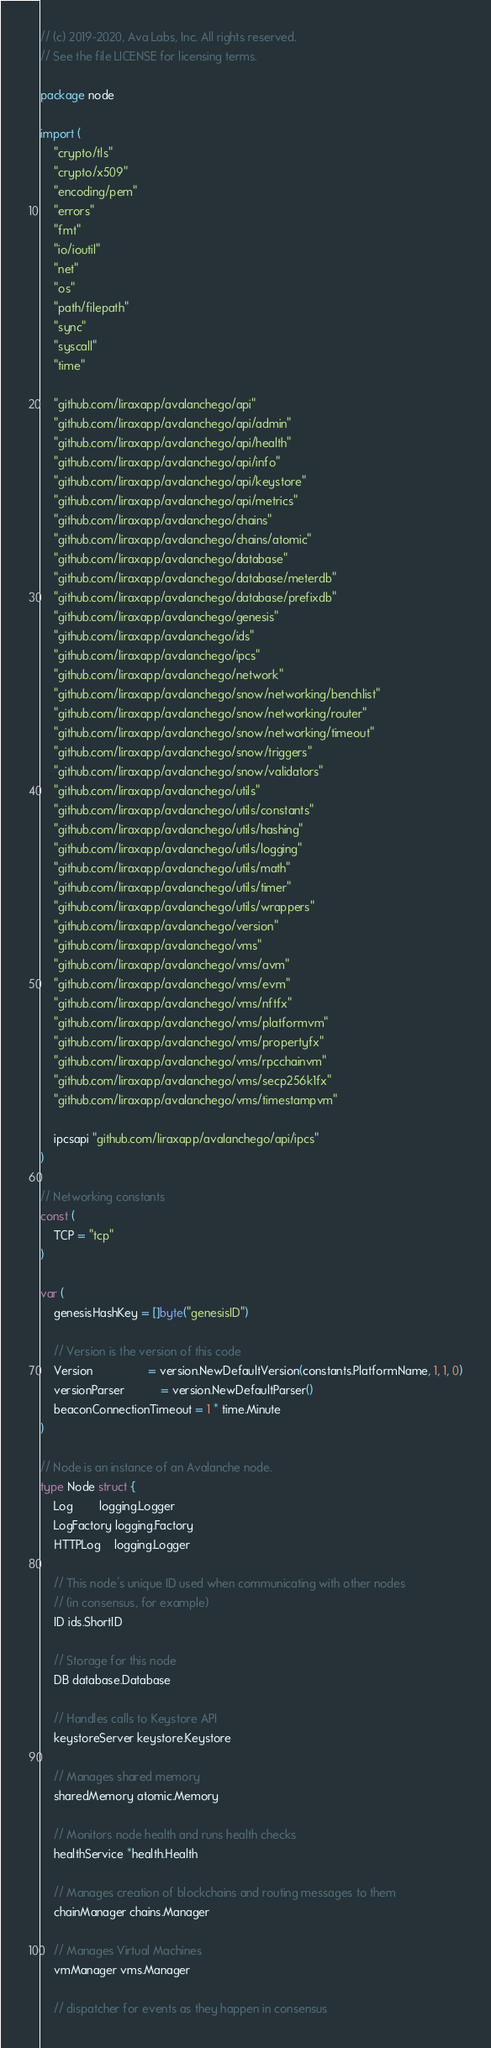Convert code to text. <code><loc_0><loc_0><loc_500><loc_500><_Go_>// (c) 2019-2020, Ava Labs, Inc. All rights reserved.
// See the file LICENSE for licensing terms.

package node

import (
	"crypto/tls"
	"crypto/x509"
	"encoding/pem"
	"errors"
	"fmt"
	"io/ioutil"
	"net"
	"os"
	"path/filepath"
	"sync"
	"syscall"
	"time"

	"github.com/liraxapp/avalanchego/api"
	"github.com/liraxapp/avalanchego/api/admin"
	"github.com/liraxapp/avalanchego/api/health"
	"github.com/liraxapp/avalanchego/api/info"
	"github.com/liraxapp/avalanchego/api/keystore"
	"github.com/liraxapp/avalanchego/api/metrics"
	"github.com/liraxapp/avalanchego/chains"
	"github.com/liraxapp/avalanchego/chains/atomic"
	"github.com/liraxapp/avalanchego/database"
	"github.com/liraxapp/avalanchego/database/meterdb"
	"github.com/liraxapp/avalanchego/database/prefixdb"
	"github.com/liraxapp/avalanchego/genesis"
	"github.com/liraxapp/avalanchego/ids"
	"github.com/liraxapp/avalanchego/ipcs"
	"github.com/liraxapp/avalanchego/network"
	"github.com/liraxapp/avalanchego/snow/networking/benchlist"
	"github.com/liraxapp/avalanchego/snow/networking/router"
	"github.com/liraxapp/avalanchego/snow/networking/timeout"
	"github.com/liraxapp/avalanchego/snow/triggers"
	"github.com/liraxapp/avalanchego/snow/validators"
	"github.com/liraxapp/avalanchego/utils"
	"github.com/liraxapp/avalanchego/utils/constants"
	"github.com/liraxapp/avalanchego/utils/hashing"
	"github.com/liraxapp/avalanchego/utils/logging"
	"github.com/liraxapp/avalanchego/utils/math"
	"github.com/liraxapp/avalanchego/utils/timer"
	"github.com/liraxapp/avalanchego/utils/wrappers"
	"github.com/liraxapp/avalanchego/version"
	"github.com/liraxapp/avalanchego/vms"
	"github.com/liraxapp/avalanchego/vms/avm"
	"github.com/liraxapp/avalanchego/vms/evm"
	"github.com/liraxapp/avalanchego/vms/nftfx"
	"github.com/liraxapp/avalanchego/vms/platformvm"
	"github.com/liraxapp/avalanchego/vms/propertyfx"
	"github.com/liraxapp/avalanchego/vms/rpcchainvm"
	"github.com/liraxapp/avalanchego/vms/secp256k1fx"
	"github.com/liraxapp/avalanchego/vms/timestampvm"

	ipcsapi "github.com/liraxapp/avalanchego/api/ipcs"
)

// Networking constants
const (
	TCP = "tcp"
)

var (
	genesisHashKey = []byte("genesisID")

	// Version is the version of this code
	Version                 = version.NewDefaultVersion(constants.PlatformName, 1, 1, 0)
	versionParser           = version.NewDefaultParser()
	beaconConnectionTimeout = 1 * time.Minute
)

// Node is an instance of an Avalanche node.
type Node struct {
	Log        logging.Logger
	LogFactory logging.Factory
	HTTPLog    logging.Logger

	// This node's unique ID used when communicating with other nodes
	// (in consensus, for example)
	ID ids.ShortID

	// Storage for this node
	DB database.Database

	// Handles calls to Keystore API
	keystoreServer keystore.Keystore

	// Manages shared memory
	sharedMemory atomic.Memory

	// Monitors node health and runs health checks
	healthService *health.Health

	// Manages creation of blockchains and routing messages to them
	chainManager chains.Manager

	// Manages Virtual Machines
	vmManager vms.Manager

	// dispatcher for events as they happen in consensus</code> 